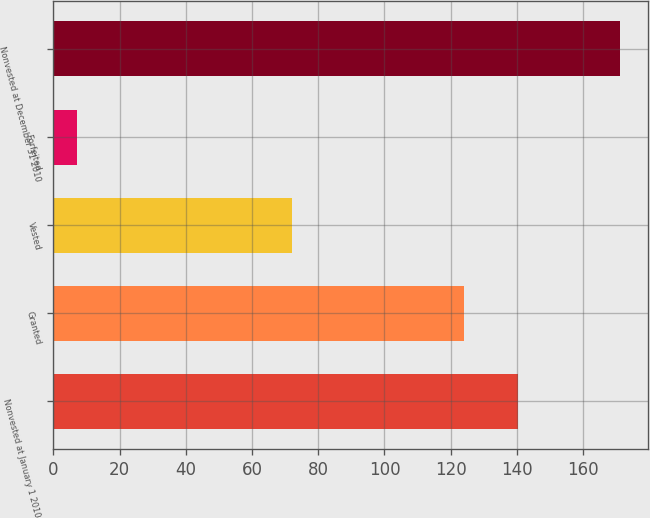Convert chart to OTSL. <chart><loc_0><loc_0><loc_500><loc_500><bar_chart><fcel>Nonvested at January 1 2010<fcel>Granted<fcel>Vested<fcel>Forfeited<fcel>Nonvested at December 31 2010<nl><fcel>140.4<fcel>124<fcel>72<fcel>7<fcel>171<nl></chart> 